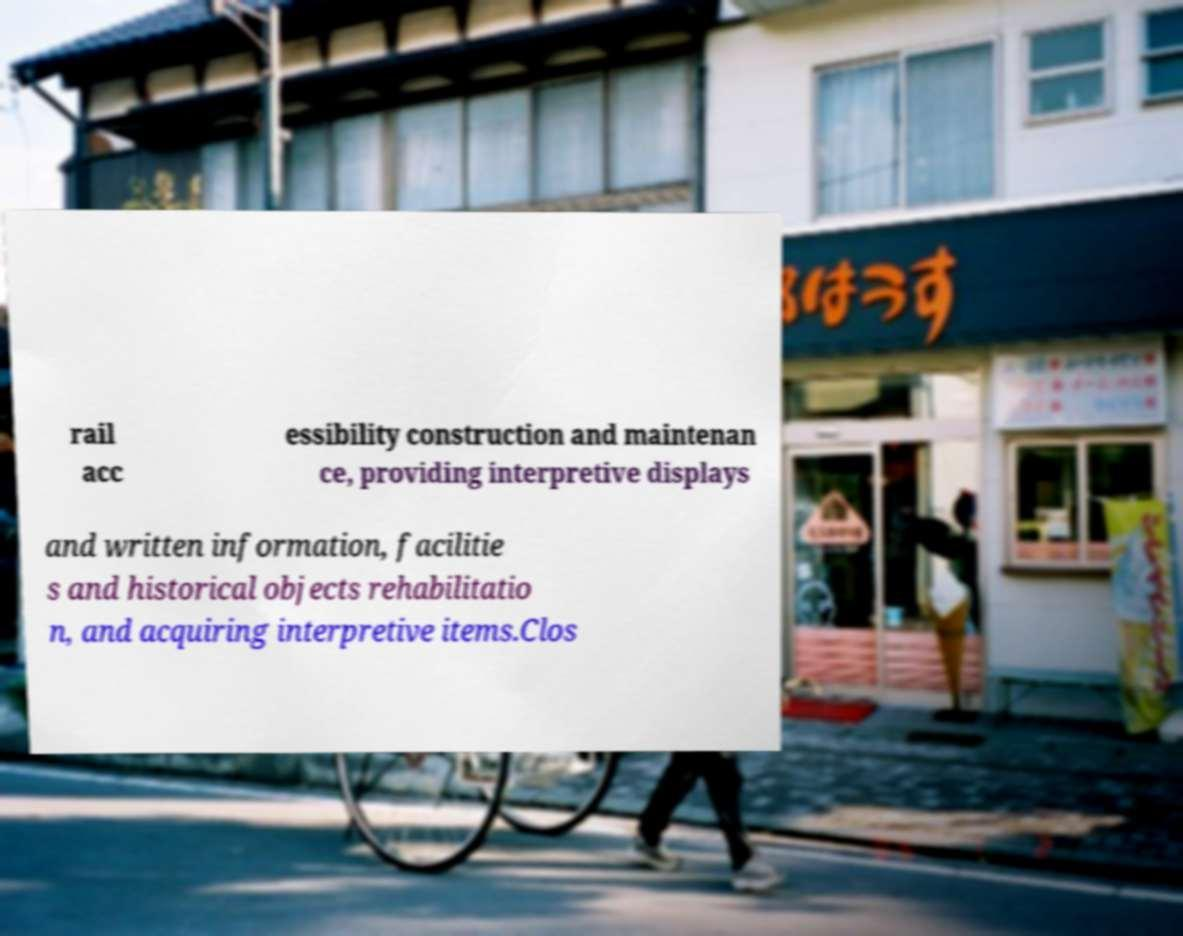Can you read and provide the text displayed in the image?This photo seems to have some interesting text. Can you extract and type it out for me? rail acc essibility construction and maintenan ce, providing interpretive displays and written information, facilitie s and historical objects rehabilitatio n, and acquiring interpretive items.Clos 